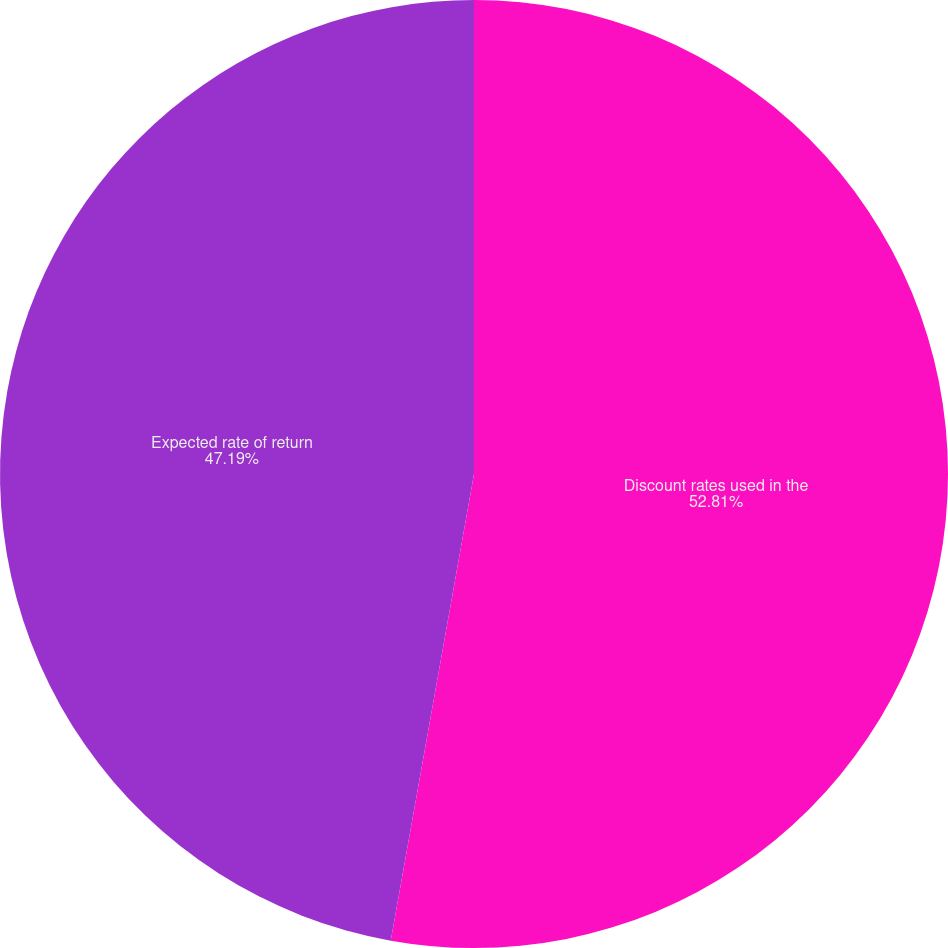Convert chart. <chart><loc_0><loc_0><loc_500><loc_500><pie_chart><fcel>Discount rates used in the<fcel>Expected rate of return<nl><fcel>52.81%<fcel>47.19%<nl></chart> 